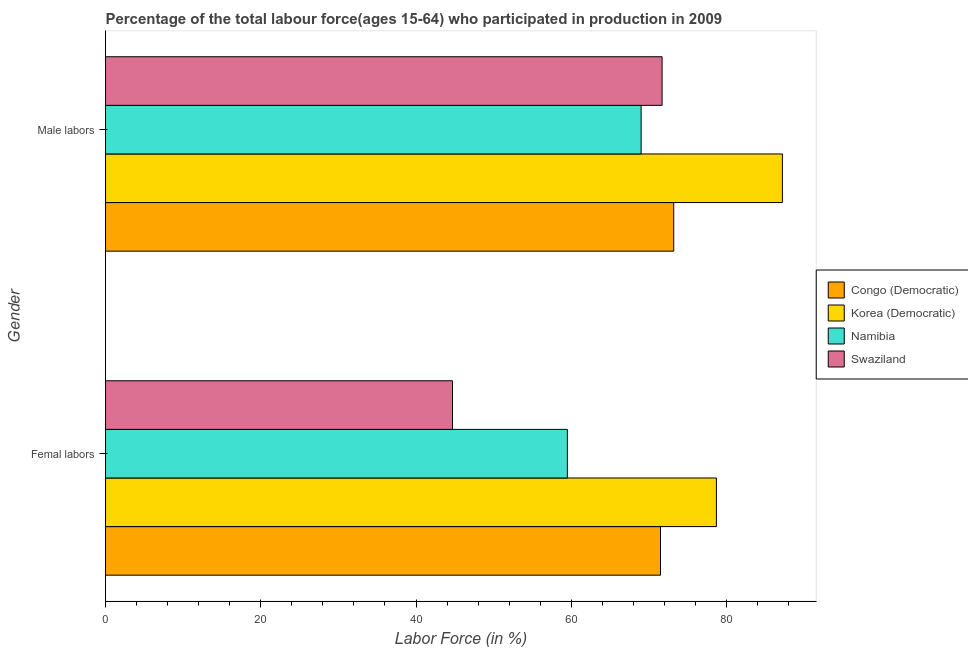How many different coloured bars are there?
Provide a succinct answer. 4. How many groups of bars are there?
Offer a terse response. 2. Are the number of bars per tick equal to the number of legend labels?
Make the answer very short. Yes. How many bars are there on the 1st tick from the bottom?
Offer a very short reply. 4. What is the label of the 1st group of bars from the top?
Offer a terse response. Male labors. What is the percentage of female labor force in Swaziland?
Keep it short and to the point. 44.7. Across all countries, what is the maximum percentage of female labor force?
Ensure brevity in your answer.  78.7. Across all countries, what is the minimum percentage of female labor force?
Ensure brevity in your answer.  44.7. In which country was the percentage of female labor force maximum?
Give a very brief answer. Korea (Democratic). In which country was the percentage of male labour force minimum?
Ensure brevity in your answer.  Namibia. What is the total percentage of male labour force in the graph?
Your answer should be very brief. 301.1. What is the difference between the percentage of female labor force in Congo (Democratic) and that in Swaziland?
Give a very brief answer. 26.8. What is the difference between the percentage of female labor force in Namibia and the percentage of male labour force in Korea (Democratic)?
Provide a succinct answer. -27.7. What is the average percentage of female labor force per country?
Your answer should be very brief. 63.6. What is the difference between the percentage of female labor force and percentage of male labour force in Namibia?
Your answer should be compact. -9.5. In how many countries, is the percentage of female labor force greater than 28 %?
Provide a succinct answer. 4. What is the ratio of the percentage of female labor force in Congo (Democratic) to that in Namibia?
Provide a succinct answer. 1.2. Is the percentage of female labor force in Congo (Democratic) less than that in Swaziland?
Offer a terse response. No. What does the 1st bar from the top in Male labors represents?
Your response must be concise. Swaziland. What does the 1st bar from the bottom in Male labors represents?
Your response must be concise. Congo (Democratic). How many bars are there?
Your answer should be compact. 8. Are all the bars in the graph horizontal?
Give a very brief answer. Yes. How many countries are there in the graph?
Make the answer very short. 4. What is the difference between two consecutive major ticks on the X-axis?
Your response must be concise. 20. Are the values on the major ticks of X-axis written in scientific E-notation?
Your response must be concise. No. Does the graph contain any zero values?
Offer a terse response. No. How are the legend labels stacked?
Give a very brief answer. Vertical. What is the title of the graph?
Your answer should be very brief. Percentage of the total labour force(ages 15-64) who participated in production in 2009. What is the Labor Force (in %) in Congo (Democratic) in Femal labors?
Your answer should be compact. 71.5. What is the Labor Force (in %) in Korea (Democratic) in Femal labors?
Provide a succinct answer. 78.7. What is the Labor Force (in %) of Namibia in Femal labors?
Keep it short and to the point. 59.5. What is the Labor Force (in %) of Swaziland in Femal labors?
Keep it short and to the point. 44.7. What is the Labor Force (in %) of Congo (Democratic) in Male labors?
Make the answer very short. 73.2. What is the Labor Force (in %) in Korea (Democratic) in Male labors?
Your answer should be very brief. 87.2. What is the Labor Force (in %) of Swaziland in Male labors?
Give a very brief answer. 71.7. Across all Gender, what is the maximum Labor Force (in %) of Congo (Democratic)?
Ensure brevity in your answer.  73.2. Across all Gender, what is the maximum Labor Force (in %) of Korea (Democratic)?
Give a very brief answer. 87.2. Across all Gender, what is the maximum Labor Force (in %) in Swaziland?
Offer a very short reply. 71.7. Across all Gender, what is the minimum Labor Force (in %) of Congo (Democratic)?
Your response must be concise. 71.5. Across all Gender, what is the minimum Labor Force (in %) in Korea (Democratic)?
Ensure brevity in your answer.  78.7. Across all Gender, what is the minimum Labor Force (in %) of Namibia?
Keep it short and to the point. 59.5. Across all Gender, what is the minimum Labor Force (in %) of Swaziland?
Your answer should be compact. 44.7. What is the total Labor Force (in %) in Congo (Democratic) in the graph?
Your answer should be very brief. 144.7. What is the total Labor Force (in %) of Korea (Democratic) in the graph?
Ensure brevity in your answer.  165.9. What is the total Labor Force (in %) of Namibia in the graph?
Offer a very short reply. 128.5. What is the total Labor Force (in %) in Swaziland in the graph?
Your answer should be compact. 116.4. What is the difference between the Labor Force (in %) in Congo (Democratic) in Femal labors and that in Male labors?
Provide a short and direct response. -1.7. What is the difference between the Labor Force (in %) of Korea (Democratic) in Femal labors and that in Male labors?
Your answer should be very brief. -8.5. What is the difference between the Labor Force (in %) of Swaziland in Femal labors and that in Male labors?
Ensure brevity in your answer.  -27. What is the difference between the Labor Force (in %) in Congo (Democratic) in Femal labors and the Labor Force (in %) in Korea (Democratic) in Male labors?
Offer a terse response. -15.7. What is the difference between the Labor Force (in %) of Congo (Democratic) in Femal labors and the Labor Force (in %) of Swaziland in Male labors?
Your answer should be compact. -0.2. What is the average Labor Force (in %) of Congo (Democratic) per Gender?
Ensure brevity in your answer.  72.35. What is the average Labor Force (in %) in Korea (Democratic) per Gender?
Your answer should be very brief. 82.95. What is the average Labor Force (in %) of Namibia per Gender?
Your answer should be compact. 64.25. What is the average Labor Force (in %) of Swaziland per Gender?
Offer a very short reply. 58.2. What is the difference between the Labor Force (in %) in Congo (Democratic) and Labor Force (in %) in Namibia in Femal labors?
Offer a very short reply. 12. What is the difference between the Labor Force (in %) of Congo (Democratic) and Labor Force (in %) of Swaziland in Femal labors?
Keep it short and to the point. 26.8. What is the difference between the Labor Force (in %) in Korea (Democratic) and Labor Force (in %) in Swaziland in Femal labors?
Provide a short and direct response. 34. What is the difference between the Labor Force (in %) of Congo (Democratic) and Labor Force (in %) of Korea (Democratic) in Male labors?
Make the answer very short. -14. What is the difference between the Labor Force (in %) of Congo (Democratic) and Labor Force (in %) of Namibia in Male labors?
Your answer should be very brief. 4.2. What is the difference between the Labor Force (in %) of Korea (Democratic) and Labor Force (in %) of Swaziland in Male labors?
Keep it short and to the point. 15.5. What is the difference between the Labor Force (in %) of Namibia and Labor Force (in %) of Swaziland in Male labors?
Your response must be concise. -2.7. What is the ratio of the Labor Force (in %) of Congo (Democratic) in Femal labors to that in Male labors?
Offer a terse response. 0.98. What is the ratio of the Labor Force (in %) of Korea (Democratic) in Femal labors to that in Male labors?
Give a very brief answer. 0.9. What is the ratio of the Labor Force (in %) of Namibia in Femal labors to that in Male labors?
Give a very brief answer. 0.86. What is the ratio of the Labor Force (in %) in Swaziland in Femal labors to that in Male labors?
Your answer should be compact. 0.62. What is the difference between the highest and the second highest Labor Force (in %) in Namibia?
Ensure brevity in your answer.  9.5. What is the difference between the highest and the second highest Labor Force (in %) in Swaziland?
Make the answer very short. 27. What is the difference between the highest and the lowest Labor Force (in %) of Namibia?
Offer a terse response. 9.5. 